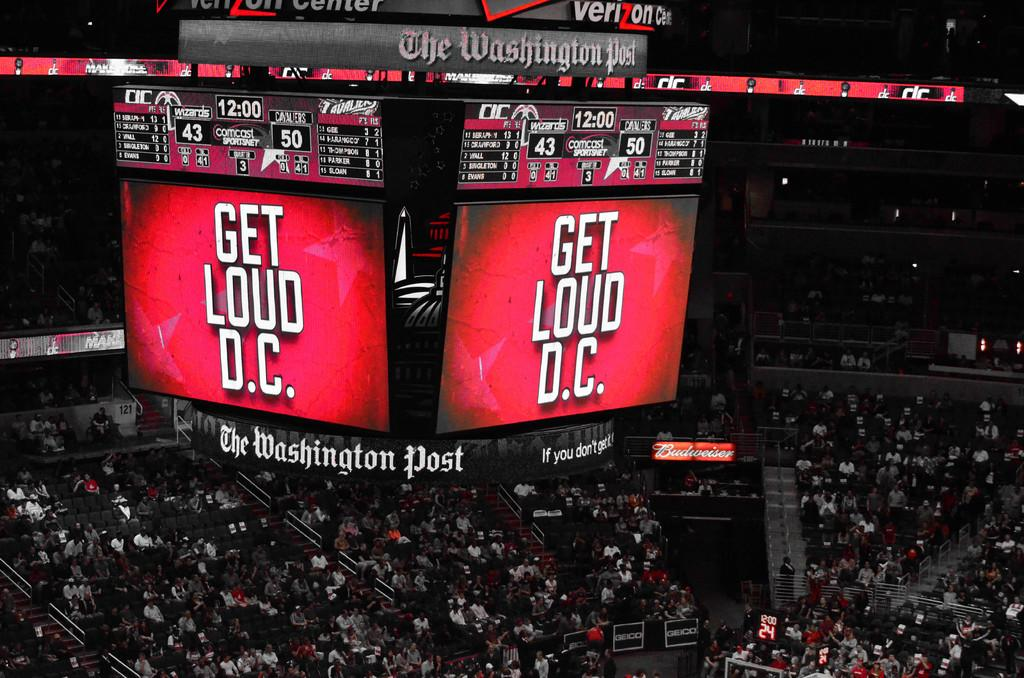<image>
Give a short and clear explanation of the subsequent image. A large display at a sporting event reads Get Loud D.C. 